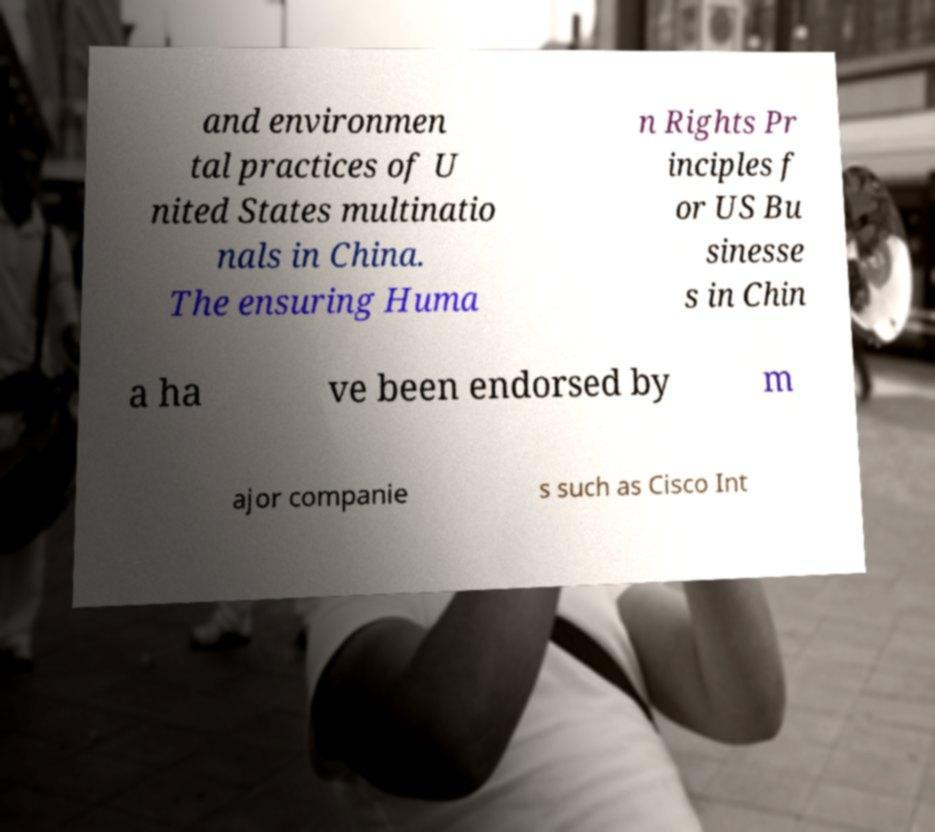Can you read and provide the text displayed in the image?This photo seems to have some interesting text. Can you extract and type it out for me? and environmen tal practices of U nited States multinatio nals in China. The ensuring Huma n Rights Pr inciples f or US Bu sinesse s in Chin a ha ve been endorsed by m ajor companie s such as Cisco Int 